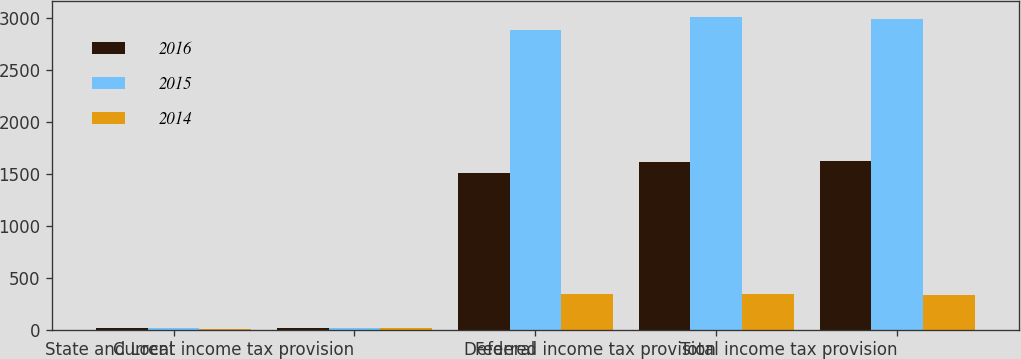Convert chart to OTSL. <chart><loc_0><loc_0><loc_500><loc_500><stacked_bar_chart><ecel><fcel>State and Local<fcel>Current income tax provision<fcel>Federal<fcel>Deferred income tax provision<fcel>Total income tax provision<nl><fcel>2016<fcel>12<fcel>12<fcel>1508<fcel>1611<fcel>1623<nl><fcel>2015<fcel>20<fcel>20<fcel>2884<fcel>3014<fcel>2994<nl><fcel>2014<fcel>9<fcel>16<fcel>345<fcel>346<fcel>330<nl></chart> 